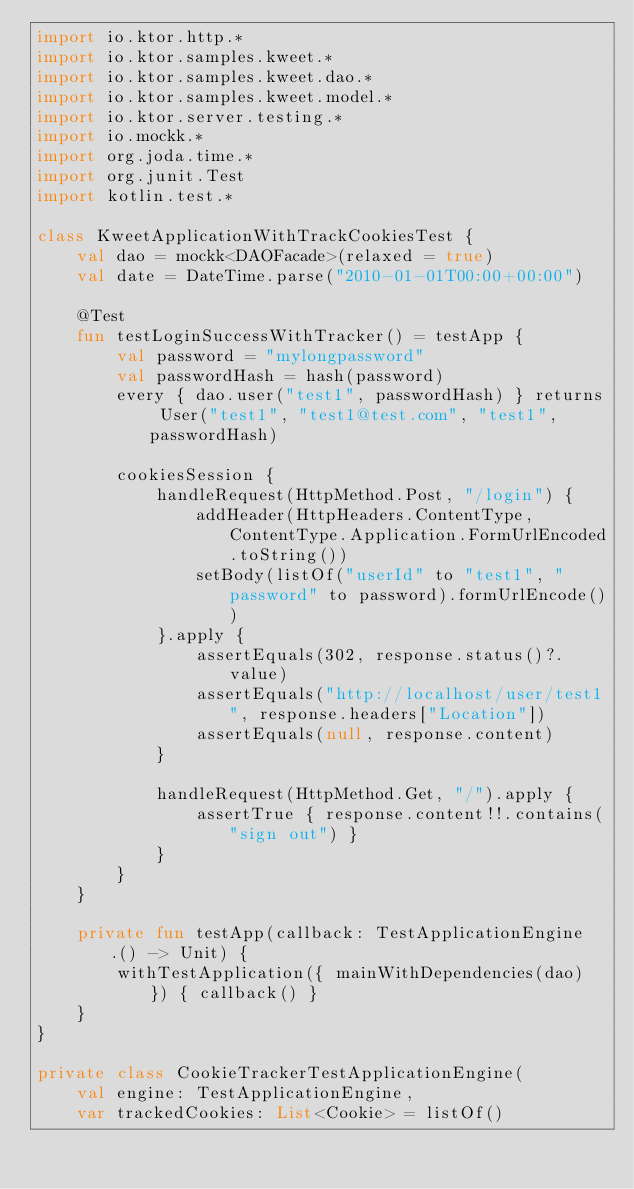Convert code to text. <code><loc_0><loc_0><loc_500><loc_500><_Kotlin_>import io.ktor.http.*
import io.ktor.samples.kweet.*
import io.ktor.samples.kweet.dao.*
import io.ktor.samples.kweet.model.*
import io.ktor.server.testing.*
import io.mockk.*
import org.joda.time.*
import org.junit.Test
import kotlin.test.*

class KweetApplicationWithTrackCookiesTest {
    val dao = mockk<DAOFacade>(relaxed = true)
    val date = DateTime.parse("2010-01-01T00:00+00:00")

    @Test
    fun testLoginSuccessWithTracker() = testApp {
        val password = "mylongpassword"
        val passwordHash = hash(password)
        every { dao.user("test1", passwordHash) } returns User("test1", "test1@test.com", "test1", passwordHash)

        cookiesSession {
            handleRequest(HttpMethod.Post, "/login") {
                addHeader(HttpHeaders.ContentType, ContentType.Application.FormUrlEncoded.toString())
                setBody(listOf("userId" to "test1", "password" to password).formUrlEncode())
            }.apply {
                assertEquals(302, response.status()?.value)
                assertEquals("http://localhost/user/test1", response.headers["Location"])
                assertEquals(null, response.content)
            }

            handleRequest(HttpMethod.Get, "/").apply {
                assertTrue { response.content!!.contains("sign out") }
            }
        }
    }

    private fun testApp(callback: TestApplicationEngine.() -> Unit) {
        withTestApplication({ mainWithDependencies(dao) }) { callback() }
    }
}

private class CookieTrackerTestApplicationEngine(
    val engine: TestApplicationEngine,
    var trackedCookies: List<Cookie> = listOf()</code> 